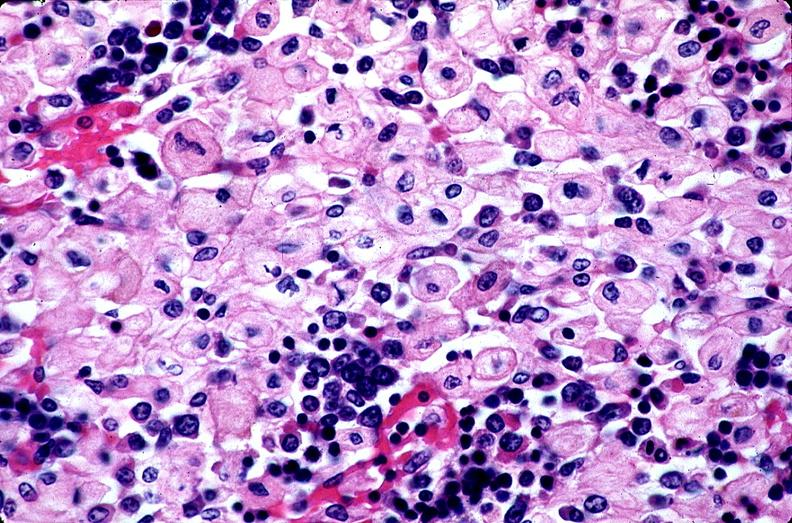s fibrotic lesion present?
Answer the question using a single word or phrase. No 